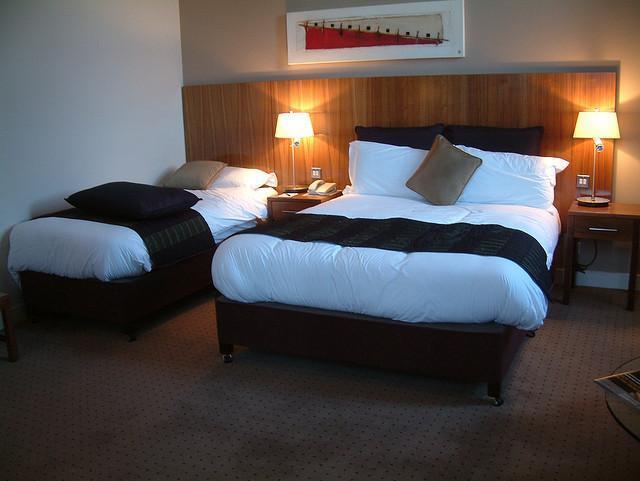How many lamps are there?
Give a very brief answer. 2. How many beds are there?
Give a very brief answer. 2. 